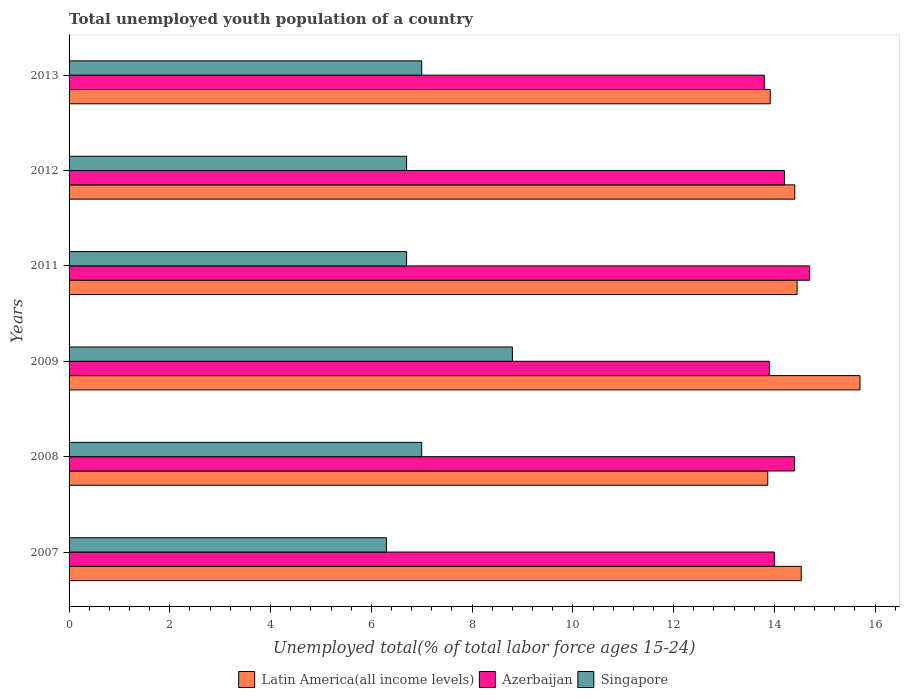How many different coloured bars are there?
Make the answer very short. 3. How many groups of bars are there?
Keep it short and to the point. 6. What is the percentage of total unemployed youth population of a country in Latin America(all income levels) in 2008?
Offer a terse response. 13.87. Across all years, what is the maximum percentage of total unemployed youth population of a country in Latin America(all income levels)?
Offer a very short reply. 15.7. Across all years, what is the minimum percentage of total unemployed youth population of a country in Singapore?
Your answer should be very brief. 6.3. In which year was the percentage of total unemployed youth population of a country in Latin America(all income levels) maximum?
Your response must be concise. 2009. What is the total percentage of total unemployed youth population of a country in Latin America(all income levels) in the graph?
Your response must be concise. 86.88. What is the difference between the percentage of total unemployed youth population of a country in Latin America(all income levels) in 2007 and that in 2012?
Your answer should be very brief. 0.13. What is the difference between the percentage of total unemployed youth population of a country in Azerbaijan in 2009 and the percentage of total unemployed youth population of a country in Latin America(all income levels) in 2011?
Offer a very short reply. -0.55. What is the average percentage of total unemployed youth population of a country in Azerbaijan per year?
Make the answer very short. 14.17. In the year 2011, what is the difference between the percentage of total unemployed youth population of a country in Azerbaijan and percentage of total unemployed youth population of a country in Singapore?
Your response must be concise. 8. In how many years, is the percentage of total unemployed youth population of a country in Latin America(all income levels) greater than 3.2 %?
Give a very brief answer. 6. What is the ratio of the percentage of total unemployed youth population of a country in Latin America(all income levels) in 2008 to that in 2009?
Give a very brief answer. 0.88. Is the percentage of total unemployed youth population of a country in Singapore in 2009 less than that in 2011?
Ensure brevity in your answer.  No. Is the difference between the percentage of total unemployed youth population of a country in Azerbaijan in 2007 and 2011 greater than the difference between the percentage of total unemployed youth population of a country in Singapore in 2007 and 2011?
Ensure brevity in your answer.  No. What is the difference between the highest and the second highest percentage of total unemployed youth population of a country in Singapore?
Your answer should be very brief. 1.8. What is the difference between the highest and the lowest percentage of total unemployed youth population of a country in Azerbaijan?
Make the answer very short. 0.9. What does the 2nd bar from the top in 2013 represents?
Offer a very short reply. Azerbaijan. What does the 3rd bar from the bottom in 2008 represents?
Give a very brief answer. Singapore. Is it the case that in every year, the sum of the percentage of total unemployed youth population of a country in Singapore and percentage of total unemployed youth population of a country in Latin America(all income levels) is greater than the percentage of total unemployed youth population of a country in Azerbaijan?
Your response must be concise. Yes. How many bars are there?
Give a very brief answer. 18. Are the values on the major ticks of X-axis written in scientific E-notation?
Offer a terse response. No. Does the graph contain any zero values?
Your answer should be very brief. No. Where does the legend appear in the graph?
Provide a succinct answer. Bottom center. How many legend labels are there?
Provide a short and direct response. 3. How are the legend labels stacked?
Your answer should be very brief. Horizontal. What is the title of the graph?
Offer a terse response. Total unemployed youth population of a country. Does "Syrian Arab Republic" appear as one of the legend labels in the graph?
Make the answer very short. No. What is the label or title of the X-axis?
Your answer should be compact. Unemployed total(% of total labor force ages 15-24). What is the label or title of the Y-axis?
Your response must be concise. Years. What is the Unemployed total(% of total labor force ages 15-24) in Latin America(all income levels) in 2007?
Ensure brevity in your answer.  14.53. What is the Unemployed total(% of total labor force ages 15-24) in Singapore in 2007?
Make the answer very short. 6.3. What is the Unemployed total(% of total labor force ages 15-24) in Latin America(all income levels) in 2008?
Ensure brevity in your answer.  13.87. What is the Unemployed total(% of total labor force ages 15-24) of Azerbaijan in 2008?
Offer a terse response. 14.4. What is the Unemployed total(% of total labor force ages 15-24) in Singapore in 2008?
Provide a succinct answer. 7. What is the Unemployed total(% of total labor force ages 15-24) in Latin America(all income levels) in 2009?
Keep it short and to the point. 15.7. What is the Unemployed total(% of total labor force ages 15-24) in Azerbaijan in 2009?
Your response must be concise. 13.9. What is the Unemployed total(% of total labor force ages 15-24) of Singapore in 2009?
Offer a terse response. 8.8. What is the Unemployed total(% of total labor force ages 15-24) of Latin America(all income levels) in 2011?
Keep it short and to the point. 14.45. What is the Unemployed total(% of total labor force ages 15-24) in Azerbaijan in 2011?
Ensure brevity in your answer.  14.7. What is the Unemployed total(% of total labor force ages 15-24) of Singapore in 2011?
Provide a short and direct response. 6.7. What is the Unemployed total(% of total labor force ages 15-24) of Latin America(all income levels) in 2012?
Offer a terse response. 14.41. What is the Unemployed total(% of total labor force ages 15-24) of Azerbaijan in 2012?
Your response must be concise. 14.2. What is the Unemployed total(% of total labor force ages 15-24) in Singapore in 2012?
Your answer should be very brief. 6.7. What is the Unemployed total(% of total labor force ages 15-24) of Latin America(all income levels) in 2013?
Ensure brevity in your answer.  13.92. What is the Unemployed total(% of total labor force ages 15-24) of Azerbaijan in 2013?
Keep it short and to the point. 13.8. What is the Unemployed total(% of total labor force ages 15-24) of Singapore in 2013?
Keep it short and to the point. 7. Across all years, what is the maximum Unemployed total(% of total labor force ages 15-24) of Latin America(all income levels)?
Your answer should be compact. 15.7. Across all years, what is the maximum Unemployed total(% of total labor force ages 15-24) of Azerbaijan?
Offer a very short reply. 14.7. Across all years, what is the maximum Unemployed total(% of total labor force ages 15-24) of Singapore?
Your answer should be compact. 8.8. Across all years, what is the minimum Unemployed total(% of total labor force ages 15-24) in Latin America(all income levels)?
Make the answer very short. 13.87. Across all years, what is the minimum Unemployed total(% of total labor force ages 15-24) of Azerbaijan?
Your answer should be compact. 13.8. Across all years, what is the minimum Unemployed total(% of total labor force ages 15-24) in Singapore?
Your answer should be very brief. 6.3. What is the total Unemployed total(% of total labor force ages 15-24) of Latin America(all income levels) in the graph?
Ensure brevity in your answer.  86.88. What is the total Unemployed total(% of total labor force ages 15-24) in Singapore in the graph?
Keep it short and to the point. 42.5. What is the difference between the Unemployed total(% of total labor force ages 15-24) in Latin America(all income levels) in 2007 and that in 2008?
Keep it short and to the point. 0.66. What is the difference between the Unemployed total(% of total labor force ages 15-24) in Azerbaijan in 2007 and that in 2008?
Offer a terse response. -0.4. What is the difference between the Unemployed total(% of total labor force ages 15-24) of Singapore in 2007 and that in 2008?
Ensure brevity in your answer.  -0.7. What is the difference between the Unemployed total(% of total labor force ages 15-24) of Latin America(all income levels) in 2007 and that in 2009?
Your answer should be very brief. -1.17. What is the difference between the Unemployed total(% of total labor force ages 15-24) of Latin America(all income levels) in 2007 and that in 2011?
Keep it short and to the point. 0.08. What is the difference between the Unemployed total(% of total labor force ages 15-24) of Singapore in 2007 and that in 2011?
Your response must be concise. -0.4. What is the difference between the Unemployed total(% of total labor force ages 15-24) in Latin America(all income levels) in 2007 and that in 2012?
Your answer should be compact. 0.13. What is the difference between the Unemployed total(% of total labor force ages 15-24) of Singapore in 2007 and that in 2012?
Provide a succinct answer. -0.4. What is the difference between the Unemployed total(% of total labor force ages 15-24) of Latin America(all income levels) in 2007 and that in 2013?
Provide a succinct answer. 0.62. What is the difference between the Unemployed total(% of total labor force ages 15-24) in Latin America(all income levels) in 2008 and that in 2009?
Keep it short and to the point. -1.83. What is the difference between the Unemployed total(% of total labor force ages 15-24) in Singapore in 2008 and that in 2009?
Your response must be concise. -1.8. What is the difference between the Unemployed total(% of total labor force ages 15-24) of Latin America(all income levels) in 2008 and that in 2011?
Make the answer very short. -0.58. What is the difference between the Unemployed total(% of total labor force ages 15-24) in Singapore in 2008 and that in 2011?
Offer a terse response. 0.3. What is the difference between the Unemployed total(% of total labor force ages 15-24) in Latin America(all income levels) in 2008 and that in 2012?
Your response must be concise. -0.54. What is the difference between the Unemployed total(% of total labor force ages 15-24) of Singapore in 2008 and that in 2012?
Offer a very short reply. 0.3. What is the difference between the Unemployed total(% of total labor force ages 15-24) of Latin America(all income levels) in 2008 and that in 2013?
Provide a succinct answer. -0.05. What is the difference between the Unemployed total(% of total labor force ages 15-24) in Latin America(all income levels) in 2009 and that in 2011?
Your answer should be compact. 1.25. What is the difference between the Unemployed total(% of total labor force ages 15-24) in Azerbaijan in 2009 and that in 2011?
Keep it short and to the point. -0.8. What is the difference between the Unemployed total(% of total labor force ages 15-24) in Singapore in 2009 and that in 2011?
Provide a short and direct response. 2.1. What is the difference between the Unemployed total(% of total labor force ages 15-24) of Latin America(all income levels) in 2009 and that in 2012?
Your answer should be very brief. 1.29. What is the difference between the Unemployed total(% of total labor force ages 15-24) in Latin America(all income levels) in 2009 and that in 2013?
Your answer should be compact. 1.78. What is the difference between the Unemployed total(% of total labor force ages 15-24) in Azerbaijan in 2009 and that in 2013?
Make the answer very short. 0.1. What is the difference between the Unemployed total(% of total labor force ages 15-24) of Latin America(all income levels) in 2011 and that in 2012?
Ensure brevity in your answer.  0.05. What is the difference between the Unemployed total(% of total labor force ages 15-24) in Singapore in 2011 and that in 2012?
Ensure brevity in your answer.  0. What is the difference between the Unemployed total(% of total labor force ages 15-24) of Latin America(all income levels) in 2011 and that in 2013?
Give a very brief answer. 0.53. What is the difference between the Unemployed total(% of total labor force ages 15-24) of Azerbaijan in 2011 and that in 2013?
Provide a short and direct response. 0.9. What is the difference between the Unemployed total(% of total labor force ages 15-24) in Latin America(all income levels) in 2012 and that in 2013?
Your answer should be very brief. 0.49. What is the difference between the Unemployed total(% of total labor force ages 15-24) in Azerbaijan in 2012 and that in 2013?
Provide a short and direct response. 0.4. What is the difference between the Unemployed total(% of total labor force ages 15-24) in Latin America(all income levels) in 2007 and the Unemployed total(% of total labor force ages 15-24) in Azerbaijan in 2008?
Your response must be concise. 0.13. What is the difference between the Unemployed total(% of total labor force ages 15-24) of Latin America(all income levels) in 2007 and the Unemployed total(% of total labor force ages 15-24) of Singapore in 2008?
Your answer should be very brief. 7.53. What is the difference between the Unemployed total(% of total labor force ages 15-24) of Azerbaijan in 2007 and the Unemployed total(% of total labor force ages 15-24) of Singapore in 2008?
Your answer should be very brief. 7. What is the difference between the Unemployed total(% of total labor force ages 15-24) of Latin America(all income levels) in 2007 and the Unemployed total(% of total labor force ages 15-24) of Azerbaijan in 2009?
Make the answer very short. 0.63. What is the difference between the Unemployed total(% of total labor force ages 15-24) in Latin America(all income levels) in 2007 and the Unemployed total(% of total labor force ages 15-24) in Singapore in 2009?
Ensure brevity in your answer.  5.73. What is the difference between the Unemployed total(% of total labor force ages 15-24) in Azerbaijan in 2007 and the Unemployed total(% of total labor force ages 15-24) in Singapore in 2009?
Provide a short and direct response. 5.2. What is the difference between the Unemployed total(% of total labor force ages 15-24) in Latin America(all income levels) in 2007 and the Unemployed total(% of total labor force ages 15-24) in Singapore in 2011?
Offer a very short reply. 7.83. What is the difference between the Unemployed total(% of total labor force ages 15-24) in Latin America(all income levels) in 2007 and the Unemployed total(% of total labor force ages 15-24) in Singapore in 2012?
Keep it short and to the point. 7.83. What is the difference between the Unemployed total(% of total labor force ages 15-24) in Azerbaijan in 2007 and the Unemployed total(% of total labor force ages 15-24) in Singapore in 2012?
Give a very brief answer. 7.3. What is the difference between the Unemployed total(% of total labor force ages 15-24) of Latin America(all income levels) in 2007 and the Unemployed total(% of total labor force ages 15-24) of Azerbaijan in 2013?
Provide a short and direct response. 0.73. What is the difference between the Unemployed total(% of total labor force ages 15-24) in Latin America(all income levels) in 2007 and the Unemployed total(% of total labor force ages 15-24) in Singapore in 2013?
Your answer should be very brief. 7.53. What is the difference between the Unemployed total(% of total labor force ages 15-24) in Latin America(all income levels) in 2008 and the Unemployed total(% of total labor force ages 15-24) in Azerbaijan in 2009?
Your answer should be compact. -0.03. What is the difference between the Unemployed total(% of total labor force ages 15-24) of Latin America(all income levels) in 2008 and the Unemployed total(% of total labor force ages 15-24) of Singapore in 2009?
Ensure brevity in your answer.  5.07. What is the difference between the Unemployed total(% of total labor force ages 15-24) in Latin America(all income levels) in 2008 and the Unemployed total(% of total labor force ages 15-24) in Azerbaijan in 2011?
Make the answer very short. -0.83. What is the difference between the Unemployed total(% of total labor force ages 15-24) in Latin America(all income levels) in 2008 and the Unemployed total(% of total labor force ages 15-24) in Singapore in 2011?
Offer a terse response. 7.17. What is the difference between the Unemployed total(% of total labor force ages 15-24) of Azerbaijan in 2008 and the Unemployed total(% of total labor force ages 15-24) of Singapore in 2011?
Keep it short and to the point. 7.7. What is the difference between the Unemployed total(% of total labor force ages 15-24) in Latin America(all income levels) in 2008 and the Unemployed total(% of total labor force ages 15-24) in Azerbaijan in 2012?
Your answer should be compact. -0.33. What is the difference between the Unemployed total(% of total labor force ages 15-24) in Latin America(all income levels) in 2008 and the Unemployed total(% of total labor force ages 15-24) in Singapore in 2012?
Make the answer very short. 7.17. What is the difference between the Unemployed total(% of total labor force ages 15-24) of Azerbaijan in 2008 and the Unemployed total(% of total labor force ages 15-24) of Singapore in 2012?
Make the answer very short. 7.7. What is the difference between the Unemployed total(% of total labor force ages 15-24) of Latin America(all income levels) in 2008 and the Unemployed total(% of total labor force ages 15-24) of Azerbaijan in 2013?
Make the answer very short. 0.07. What is the difference between the Unemployed total(% of total labor force ages 15-24) in Latin America(all income levels) in 2008 and the Unemployed total(% of total labor force ages 15-24) in Singapore in 2013?
Offer a terse response. 6.87. What is the difference between the Unemployed total(% of total labor force ages 15-24) in Latin America(all income levels) in 2009 and the Unemployed total(% of total labor force ages 15-24) in Azerbaijan in 2011?
Provide a succinct answer. 1. What is the difference between the Unemployed total(% of total labor force ages 15-24) of Latin America(all income levels) in 2009 and the Unemployed total(% of total labor force ages 15-24) of Singapore in 2011?
Keep it short and to the point. 9. What is the difference between the Unemployed total(% of total labor force ages 15-24) in Azerbaijan in 2009 and the Unemployed total(% of total labor force ages 15-24) in Singapore in 2011?
Your answer should be very brief. 7.2. What is the difference between the Unemployed total(% of total labor force ages 15-24) in Latin America(all income levels) in 2009 and the Unemployed total(% of total labor force ages 15-24) in Azerbaijan in 2012?
Your answer should be very brief. 1.5. What is the difference between the Unemployed total(% of total labor force ages 15-24) of Latin America(all income levels) in 2009 and the Unemployed total(% of total labor force ages 15-24) of Singapore in 2012?
Ensure brevity in your answer.  9. What is the difference between the Unemployed total(% of total labor force ages 15-24) of Latin America(all income levels) in 2009 and the Unemployed total(% of total labor force ages 15-24) of Azerbaijan in 2013?
Offer a very short reply. 1.9. What is the difference between the Unemployed total(% of total labor force ages 15-24) of Latin America(all income levels) in 2009 and the Unemployed total(% of total labor force ages 15-24) of Singapore in 2013?
Ensure brevity in your answer.  8.7. What is the difference between the Unemployed total(% of total labor force ages 15-24) in Latin America(all income levels) in 2011 and the Unemployed total(% of total labor force ages 15-24) in Azerbaijan in 2012?
Your answer should be very brief. 0.25. What is the difference between the Unemployed total(% of total labor force ages 15-24) of Latin America(all income levels) in 2011 and the Unemployed total(% of total labor force ages 15-24) of Singapore in 2012?
Your answer should be very brief. 7.75. What is the difference between the Unemployed total(% of total labor force ages 15-24) of Latin America(all income levels) in 2011 and the Unemployed total(% of total labor force ages 15-24) of Azerbaijan in 2013?
Keep it short and to the point. 0.65. What is the difference between the Unemployed total(% of total labor force ages 15-24) in Latin America(all income levels) in 2011 and the Unemployed total(% of total labor force ages 15-24) in Singapore in 2013?
Your answer should be compact. 7.45. What is the difference between the Unemployed total(% of total labor force ages 15-24) of Azerbaijan in 2011 and the Unemployed total(% of total labor force ages 15-24) of Singapore in 2013?
Ensure brevity in your answer.  7.7. What is the difference between the Unemployed total(% of total labor force ages 15-24) of Latin America(all income levels) in 2012 and the Unemployed total(% of total labor force ages 15-24) of Azerbaijan in 2013?
Your response must be concise. 0.61. What is the difference between the Unemployed total(% of total labor force ages 15-24) of Latin America(all income levels) in 2012 and the Unemployed total(% of total labor force ages 15-24) of Singapore in 2013?
Give a very brief answer. 7.41. What is the average Unemployed total(% of total labor force ages 15-24) in Latin America(all income levels) per year?
Your answer should be compact. 14.48. What is the average Unemployed total(% of total labor force ages 15-24) of Azerbaijan per year?
Keep it short and to the point. 14.17. What is the average Unemployed total(% of total labor force ages 15-24) in Singapore per year?
Offer a terse response. 7.08. In the year 2007, what is the difference between the Unemployed total(% of total labor force ages 15-24) in Latin America(all income levels) and Unemployed total(% of total labor force ages 15-24) in Azerbaijan?
Make the answer very short. 0.53. In the year 2007, what is the difference between the Unemployed total(% of total labor force ages 15-24) in Latin America(all income levels) and Unemployed total(% of total labor force ages 15-24) in Singapore?
Offer a very short reply. 8.23. In the year 2007, what is the difference between the Unemployed total(% of total labor force ages 15-24) in Azerbaijan and Unemployed total(% of total labor force ages 15-24) in Singapore?
Offer a terse response. 7.7. In the year 2008, what is the difference between the Unemployed total(% of total labor force ages 15-24) of Latin America(all income levels) and Unemployed total(% of total labor force ages 15-24) of Azerbaijan?
Provide a succinct answer. -0.53. In the year 2008, what is the difference between the Unemployed total(% of total labor force ages 15-24) in Latin America(all income levels) and Unemployed total(% of total labor force ages 15-24) in Singapore?
Offer a very short reply. 6.87. In the year 2008, what is the difference between the Unemployed total(% of total labor force ages 15-24) in Azerbaijan and Unemployed total(% of total labor force ages 15-24) in Singapore?
Keep it short and to the point. 7.4. In the year 2009, what is the difference between the Unemployed total(% of total labor force ages 15-24) of Latin America(all income levels) and Unemployed total(% of total labor force ages 15-24) of Azerbaijan?
Your answer should be very brief. 1.8. In the year 2009, what is the difference between the Unemployed total(% of total labor force ages 15-24) in Latin America(all income levels) and Unemployed total(% of total labor force ages 15-24) in Singapore?
Give a very brief answer. 6.9. In the year 2011, what is the difference between the Unemployed total(% of total labor force ages 15-24) in Latin America(all income levels) and Unemployed total(% of total labor force ages 15-24) in Azerbaijan?
Your answer should be compact. -0.25. In the year 2011, what is the difference between the Unemployed total(% of total labor force ages 15-24) in Latin America(all income levels) and Unemployed total(% of total labor force ages 15-24) in Singapore?
Provide a succinct answer. 7.75. In the year 2011, what is the difference between the Unemployed total(% of total labor force ages 15-24) in Azerbaijan and Unemployed total(% of total labor force ages 15-24) in Singapore?
Make the answer very short. 8. In the year 2012, what is the difference between the Unemployed total(% of total labor force ages 15-24) in Latin America(all income levels) and Unemployed total(% of total labor force ages 15-24) in Azerbaijan?
Offer a very short reply. 0.21. In the year 2012, what is the difference between the Unemployed total(% of total labor force ages 15-24) in Latin America(all income levels) and Unemployed total(% of total labor force ages 15-24) in Singapore?
Your answer should be compact. 7.71. In the year 2012, what is the difference between the Unemployed total(% of total labor force ages 15-24) in Azerbaijan and Unemployed total(% of total labor force ages 15-24) in Singapore?
Make the answer very short. 7.5. In the year 2013, what is the difference between the Unemployed total(% of total labor force ages 15-24) of Latin America(all income levels) and Unemployed total(% of total labor force ages 15-24) of Azerbaijan?
Ensure brevity in your answer.  0.12. In the year 2013, what is the difference between the Unemployed total(% of total labor force ages 15-24) in Latin America(all income levels) and Unemployed total(% of total labor force ages 15-24) in Singapore?
Your response must be concise. 6.92. In the year 2013, what is the difference between the Unemployed total(% of total labor force ages 15-24) of Azerbaijan and Unemployed total(% of total labor force ages 15-24) of Singapore?
Offer a very short reply. 6.8. What is the ratio of the Unemployed total(% of total labor force ages 15-24) of Latin America(all income levels) in 2007 to that in 2008?
Your answer should be very brief. 1.05. What is the ratio of the Unemployed total(% of total labor force ages 15-24) in Azerbaijan in 2007 to that in 2008?
Make the answer very short. 0.97. What is the ratio of the Unemployed total(% of total labor force ages 15-24) in Singapore in 2007 to that in 2008?
Your response must be concise. 0.9. What is the ratio of the Unemployed total(% of total labor force ages 15-24) in Latin America(all income levels) in 2007 to that in 2009?
Provide a short and direct response. 0.93. What is the ratio of the Unemployed total(% of total labor force ages 15-24) in Singapore in 2007 to that in 2009?
Your answer should be very brief. 0.72. What is the ratio of the Unemployed total(% of total labor force ages 15-24) in Latin America(all income levels) in 2007 to that in 2011?
Offer a very short reply. 1.01. What is the ratio of the Unemployed total(% of total labor force ages 15-24) in Singapore in 2007 to that in 2011?
Provide a short and direct response. 0.94. What is the ratio of the Unemployed total(% of total labor force ages 15-24) in Latin America(all income levels) in 2007 to that in 2012?
Your response must be concise. 1.01. What is the ratio of the Unemployed total(% of total labor force ages 15-24) in Azerbaijan in 2007 to that in 2012?
Make the answer very short. 0.99. What is the ratio of the Unemployed total(% of total labor force ages 15-24) of Singapore in 2007 to that in 2012?
Your answer should be very brief. 0.94. What is the ratio of the Unemployed total(% of total labor force ages 15-24) in Latin America(all income levels) in 2007 to that in 2013?
Provide a short and direct response. 1.04. What is the ratio of the Unemployed total(% of total labor force ages 15-24) of Azerbaijan in 2007 to that in 2013?
Provide a short and direct response. 1.01. What is the ratio of the Unemployed total(% of total labor force ages 15-24) in Latin America(all income levels) in 2008 to that in 2009?
Offer a terse response. 0.88. What is the ratio of the Unemployed total(% of total labor force ages 15-24) in Azerbaijan in 2008 to that in 2009?
Provide a succinct answer. 1.04. What is the ratio of the Unemployed total(% of total labor force ages 15-24) in Singapore in 2008 to that in 2009?
Your answer should be very brief. 0.8. What is the ratio of the Unemployed total(% of total labor force ages 15-24) of Latin America(all income levels) in 2008 to that in 2011?
Keep it short and to the point. 0.96. What is the ratio of the Unemployed total(% of total labor force ages 15-24) of Azerbaijan in 2008 to that in 2011?
Give a very brief answer. 0.98. What is the ratio of the Unemployed total(% of total labor force ages 15-24) in Singapore in 2008 to that in 2011?
Your response must be concise. 1.04. What is the ratio of the Unemployed total(% of total labor force ages 15-24) in Latin America(all income levels) in 2008 to that in 2012?
Ensure brevity in your answer.  0.96. What is the ratio of the Unemployed total(% of total labor force ages 15-24) in Azerbaijan in 2008 to that in 2012?
Your answer should be compact. 1.01. What is the ratio of the Unemployed total(% of total labor force ages 15-24) in Singapore in 2008 to that in 2012?
Provide a succinct answer. 1.04. What is the ratio of the Unemployed total(% of total labor force ages 15-24) in Azerbaijan in 2008 to that in 2013?
Offer a terse response. 1.04. What is the ratio of the Unemployed total(% of total labor force ages 15-24) in Latin America(all income levels) in 2009 to that in 2011?
Your answer should be very brief. 1.09. What is the ratio of the Unemployed total(% of total labor force ages 15-24) in Azerbaijan in 2009 to that in 2011?
Make the answer very short. 0.95. What is the ratio of the Unemployed total(% of total labor force ages 15-24) in Singapore in 2009 to that in 2011?
Give a very brief answer. 1.31. What is the ratio of the Unemployed total(% of total labor force ages 15-24) of Latin America(all income levels) in 2009 to that in 2012?
Ensure brevity in your answer.  1.09. What is the ratio of the Unemployed total(% of total labor force ages 15-24) of Azerbaijan in 2009 to that in 2012?
Make the answer very short. 0.98. What is the ratio of the Unemployed total(% of total labor force ages 15-24) of Singapore in 2009 to that in 2012?
Offer a terse response. 1.31. What is the ratio of the Unemployed total(% of total labor force ages 15-24) in Latin America(all income levels) in 2009 to that in 2013?
Keep it short and to the point. 1.13. What is the ratio of the Unemployed total(% of total labor force ages 15-24) of Azerbaijan in 2009 to that in 2013?
Offer a very short reply. 1.01. What is the ratio of the Unemployed total(% of total labor force ages 15-24) of Singapore in 2009 to that in 2013?
Give a very brief answer. 1.26. What is the ratio of the Unemployed total(% of total labor force ages 15-24) of Azerbaijan in 2011 to that in 2012?
Your answer should be compact. 1.04. What is the ratio of the Unemployed total(% of total labor force ages 15-24) of Singapore in 2011 to that in 2012?
Your answer should be compact. 1. What is the ratio of the Unemployed total(% of total labor force ages 15-24) of Latin America(all income levels) in 2011 to that in 2013?
Provide a short and direct response. 1.04. What is the ratio of the Unemployed total(% of total labor force ages 15-24) of Azerbaijan in 2011 to that in 2013?
Your answer should be very brief. 1.07. What is the ratio of the Unemployed total(% of total labor force ages 15-24) of Singapore in 2011 to that in 2013?
Your answer should be compact. 0.96. What is the ratio of the Unemployed total(% of total labor force ages 15-24) in Latin America(all income levels) in 2012 to that in 2013?
Provide a succinct answer. 1.03. What is the ratio of the Unemployed total(% of total labor force ages 15-24) in Singapore in 2012 to that in 2013?
Offer a terse response. 0.96. What is the difference between the highest and the second highest Unemployed total(% of total labor force ages 15-24) in Latin America(all income levels)?
Make the answer very short. 1.17. What is the difference between the highest and the second highest Unemployed total(% of total labor force ages 15-24) in Azerbaijan?
Your answer should be very brief. 0.3. What is the difference between the highest and the lowest Unemployed total(% of total labor force ages 15-24) of Latin America(all income levels)?
Ensure brevity in your answer.  1.83. What is the difference between the highest and the lowest Unemployed total(% of total labor force ages 15-24) of Singapore?
Make the answer very short. 2.5. 